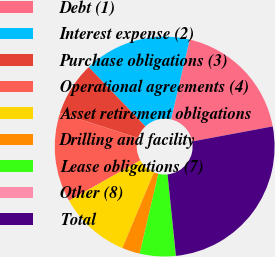<chart> <loc_0><loc_0><loc_500><loc_500><pie_chart><fcel>Debt (1)<fcel>Interest expense (2)<fcel>Purchase obligations (3)<fcel>Operational agreements (4)<fcel>Asset retirement obligations<fcel>Drilling and facility<fcel>Lease obligations (7)<fcel>Other (8)<fcel>Total<nl><fcel>18.42%<fcel>15.79%<fcel>7.9%<fcel>13.16%<fcel>10.53%<fcel>2.64%<fcel>5.27%<fcel>0.01%<fcel>26.31%<nl></chart> 